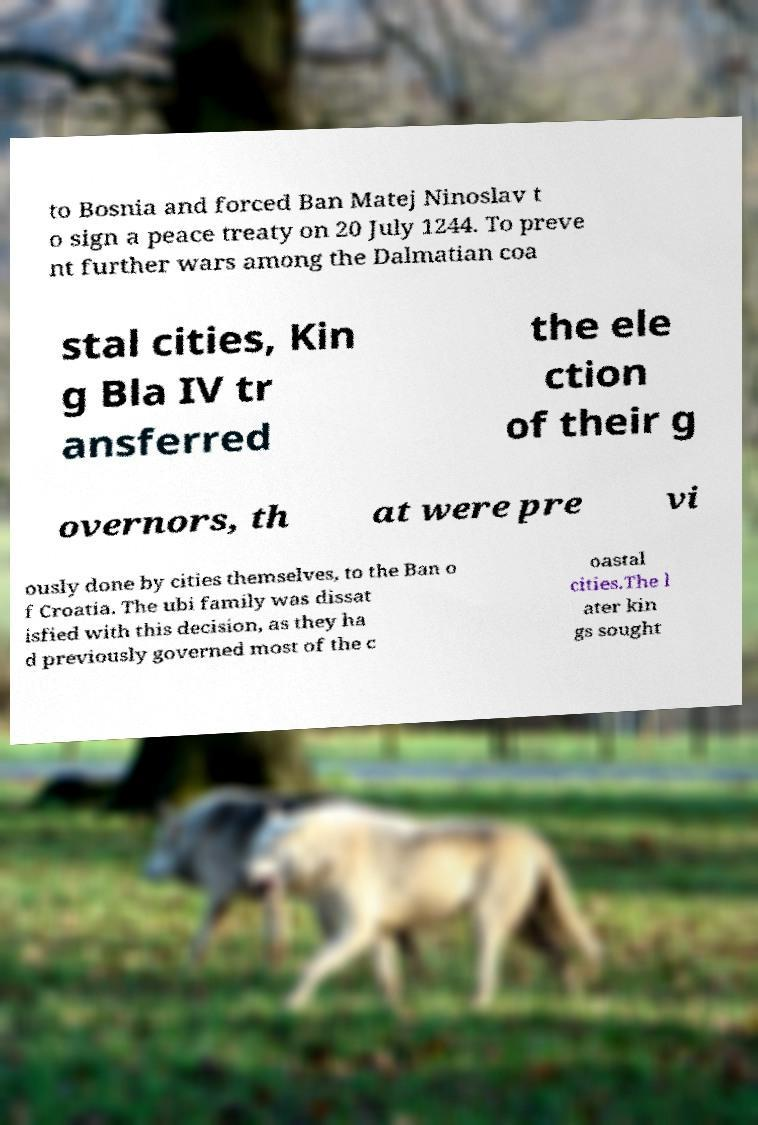For documentation purposes, I need the text within this image transcribed. Could you provide that? to Bosnia and forced Ban Matej Ninoslav t o sign a peace treaty on 20 July 1244. To preve nt further wars among the Dalmatian coa stal cities, Kin g Bla IV tr ansferred the ele ction of their g overnors, th at were pre vi ously done by cities themselves, to the Ban o f Croatia. The ubi family was dissat isfied with this decision, as they ha d previously governed most of the c oastal cities.The l ater kin gs sought 